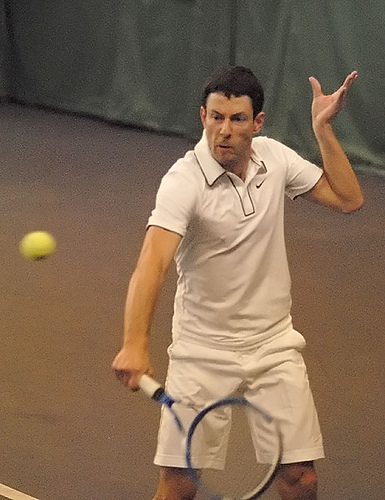<image>What letter is on the racket? I am not sure what letter is on the racket. It is unknown. Who will win? It is uncertain who will win. What letter is on the racket? I am not sure what letter is on the racket. It can be 'w', 'nike', 's', or something else. Who will win? I don't know who will win. It can be either the man or someone else. 